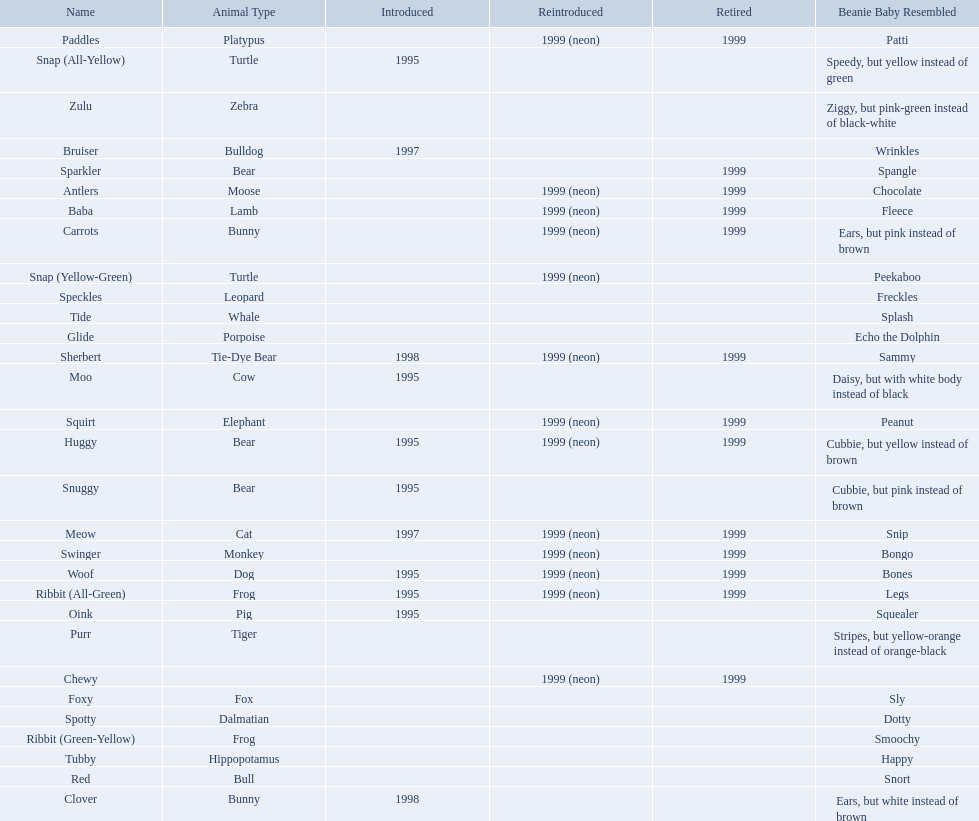Which of the listed pillow pals lack information in at least 3 categories? Chewy, Foxy, Glide, Purr, Red, Ribbit (Green-Yellow), Speckles, Spotty, Tide, Tubby, Zulu. Of those, which one lacks information in the animal type category? Chewy. 